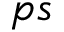<formula> <loc_0><loc_0><loc_500><loc_500>p s</formula> 